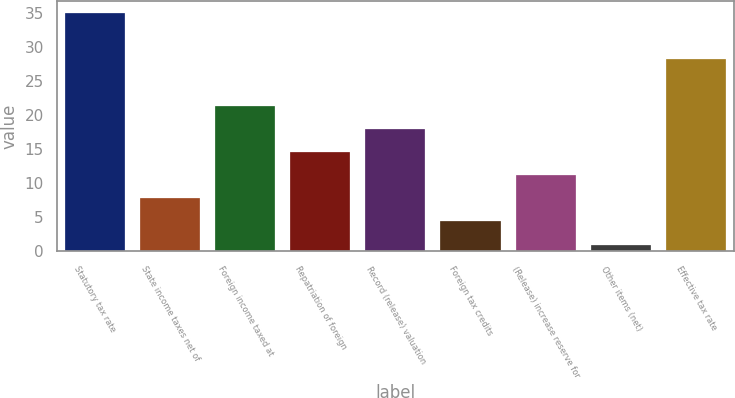Convert chart. <chart><loc_0><loc_0><loc_500><loc_500><bar_chart><fcel>Statutory tax rate<fcel>State income taxes net of<fcel>Foreign income taxed at<fcel>Repatriation of foreign<fcel>Record (release) valuation<fcel>Foreign tax credits<fcel>(Release) increase reserve for<fcel>Other items (net)<fcel>Effective tax rate<nl><fcel>35<fcel>7.8<fcel>21.4<fcel>14.6<fcel>18<fcel>4.4<fcel>11.2<fcel>1<fcel>28.2<nl></chart> 